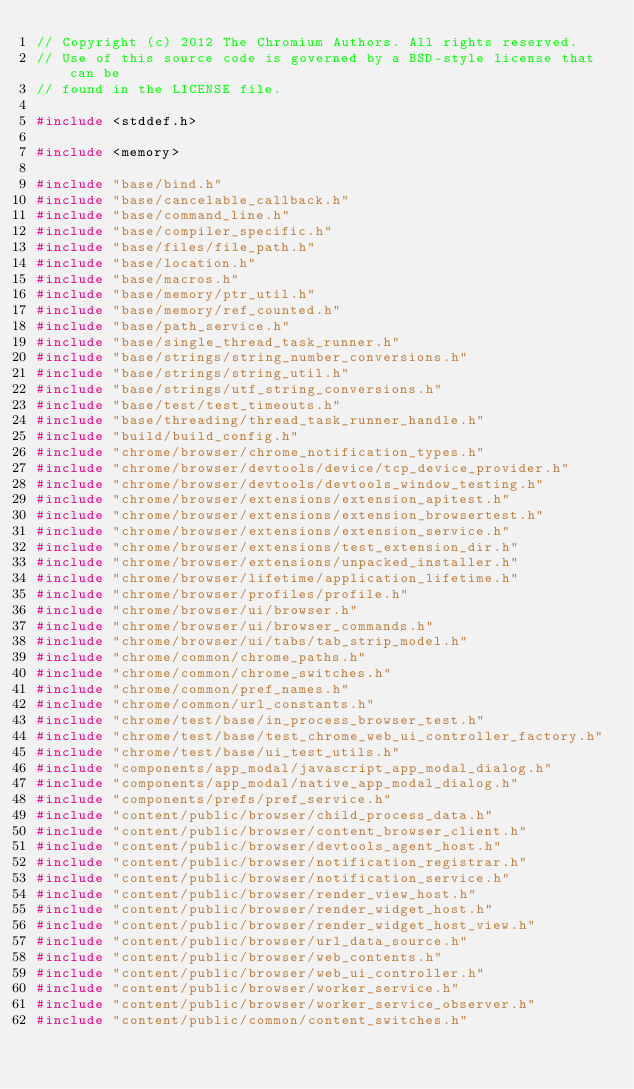<code> <loc_0><loc_0><loc_500><loc_500><_C++_>// Copyright (c) 2012 The Chromium Authors. All rights reserved.
// Use of this source code is governed by a BSD-style license that can be
// found in the LICENSE file.

#include <stddef.h>

#include <memory>

#include "base/bind.h"
#include "base/cancelable_callback.h"
#include "base/command_line.h"
#include "base/compiler_specific.h"
#include "base/files/file_path.h"
#include "base/location.h"
#include "base/macros.h"
#include "base/memory/ptr_util.h"
#include "base/memory/ref_counted.h"
#include "base/path_service.h"
#include "base/single_thread_task_runner.h"
#include "base/strings/string_number_conversions.h"
#include "base/strings/string_util.h"
#include "base/strings/utf_string_conversions.h"
#include "base/test/test_timeouts.h"
#include "base/threading/thread_task_runner_handle.h"
#include "build/build_config.h"
#include "chrome/browser/chrome_notification_types.h"
#include "chrome/browser/devtools/device/tcp_device_provider.h"
#include "chrome/browser/devtools/devtools_window_testing.h"
#include "chrome/browser/extensions/extension_apitest.h"
#include "chrome/browser/extensions/extension_browsertest.h"
#include "chrome/browser/extensions/extension_service.h"
#include "chrome/browser/extensions/test_extension_dir.h"
#include "chrome/browser/extensions/unpacked_installer.h"
#include "chrome/browser/lifetime/application_lifetime.h"
#include "chrome/browser/profiles/profile.h"
#include "chrome/browser/ui/browser.h"
#include "chrome/browser/ui/browser_commands.h"
#include "chrome/browser/ui/tabs/tab_strip_model.h"
#include "chrome/common/chrome_paths.h"
#include "chrome/common/chrome_switches.h"
#include "chrome/common/pref_names.h"
#include "chrome/common/url_constants.h"
#include "chrome/test/base/in_process_browser_test.h"
#include "chrome/test/base/test_chrome_web_ui_controller_factory.h"
#include "chrome/test/base/ui_test_utils.h"
#include "components/app_modal/javascript_app_modal_dialog.h"
#include "components/app_modal/native_app_modal_dialog.h"
#include "components/prefs/pref_service.h"
#include "content/public/browser/child_process_data.h"
#include "content/public/browser/content_browser_client.h"
#include "content/public/browser/devtools_agent_host.h"
#include "content/public/browser/notification_registrar.h"
#include "content/public/browser/notification_service.h"
#include "content/public/browser/render_view_host.h"
#include "content/public/browser/render_widget_host.h"
#include "content/public/browser/render_widget_host_view.h"
#include "content/public/browser/url_data_source.h"
#include "content/public/browser/web_contents.h"
#include "content/public/browser/web_ui_controller.h"
#include "content/public/browser/worker_service.h"
#include "content/public/browser/worker_service_observer.h"
#include "content/public/common/content_switches.h"</code> 